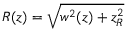Convert formula to latex. <formula><loc_0><loc_0><loc_500><loc_500>R ( z ) = \sqrt { w ^ { 2 } ( z ) + z _ { R } ^ { 2 } }</formula> 